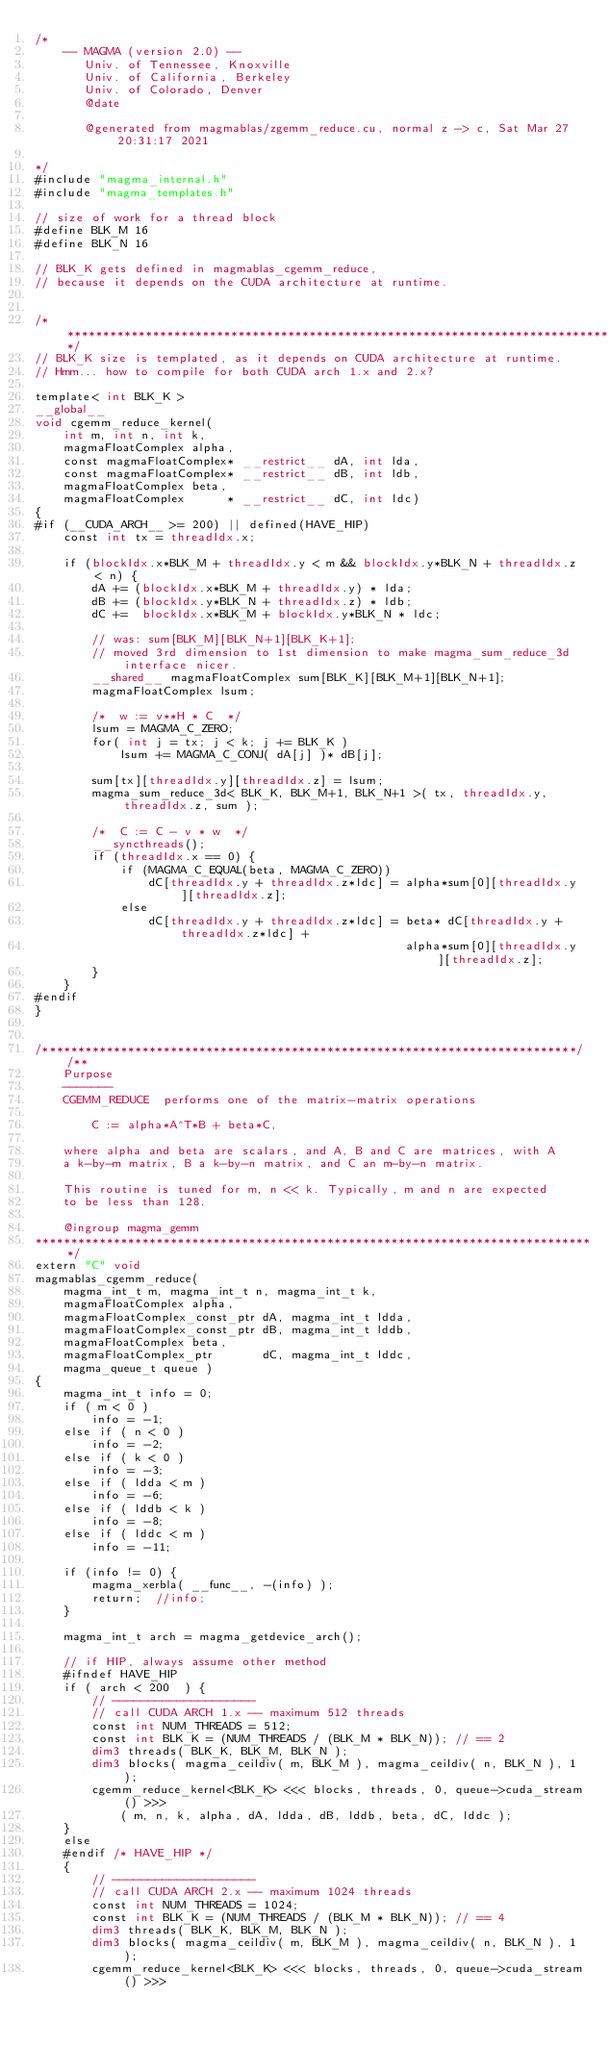<code> <loc_0><loc_0><loc_500><loc_500><_Cuda_>/*
    -- MAGMA (version 2.0) --
       Univ. of Tennessee, Knoxville
       Univ. of California, Berkeley
       Univ. of Colorado, Denver
       @date

       @generated from magmablas/zgemm_reduce.cu, normal z -> c, Sat Mar 27 20:31:17 2021

*/
#include "magma_internal.h"
#include "magma_templates.h"

// size of work for a thread block
#define BLK_M 16
#define BLK_N 16

// BLK_K gets defined in magmablas_cgemm_reduce,
// because it depends on the CUDA architecture at runtime.


/******************************************************************************/
// BLK_K size is templated, as it depends on CUDA architecture at runtime.
// Hmm... how to compile for both CUDA arch 1.x and 2.x?

template< int BLK_K >
__global__
void cgemm_reduce_kernel(
    int m, int n, int k,
    magmaFloatComplex alpha,
    const magmaFloatComplex* __restrict__ dA, int lda,
    const magmaFloatComplex* __restrict__ dB, int ldb,
    magmaFloatComplex beta,
    magmaFloatComplex      * __restrict__ dC, int ldc)
{
#if (__CUDA_ARCH__ >= 200) || defined(HAVE_HIP)
    const int tx = threadIdx.x;
    
    if (blockIdx.x*BLK_M + threadIdx.y < m && blockIdx.y*BLK_N + threadIdx.z < n) {
        dA += (blockIdx.x*BLK_M + threadIdx.y) * lda;
        dB += (blockIdx.y*BLK_N + threadIdx.z) * ldb;
        dC +=  blockIdx.x*BLK_M + blockIdx.y*BLK_N * ldc;
        
        // was: sum[BLK_M][BLK_N+1][BLK_K+1];
        // moved 3rd dimension to 1st dimension to make magma_sum_reduce_3d interface nicer.
        __shared__ magmaFloatComplex sum[BLK_K][BLK_M+1][BLK_N+1];
        magmaFloatComplex lsum;
        
        /*  w := v**H * C  */
        lsum = MAGMA_C_ZERO;
        for( int j = tx; j < k; j += BLK_K )
            lsum += MAGMA_C_CONJ( dA[j] )* dB[j];
        
        sum[tx][threadIdx.y][threadIdx.z] = lsum;
        magma_sum_reduce_3d< BLK_K, BLK_M+1, BLK_N+1 >( tx, threadIdx.y, threadIdx.z, sum );
        
        /*  C := C - v * w  */
        __syncthreads();
        if (threadIdx.x == 0) {
            if (MAGMA_C_EQUAL(beta, MAGMA_C_ZERO))
                dC[threadIdx.y + threadIdx.z*ldc] = alpha*sum[0][threadIdx.y][threadIdx.z];
            else
                dC[threadIdx.y + threadIdx.z*ldc] = beta* dC[threadIdx.y + threadIdx.z*ldc] +
                                                    alpha*sum[0][threadIdx.y][threadIdx.z];
        }
    }
#endif
}


/***************************************************************************//**
    Purpose
    -------
    CGEMM_REDUCE  performs one of the matrix-matrix operations
    
        C := alpha*A^T*B + beta*C,
    
    where alpha and beta are scalars, and A, B and C are matrices, with A
    a k-by-m matrix, B a k-by-n matrix, and C an m-by-n matrix.
    
    This routine is tuned for m, n << k. Typically, m and n are expected
    to be less than 128.

    @ingroup magma_gemm
*******************************************************************************/
extern "C" void
magmablas_cgemm_reduce(
    magma_int_t m, magma_int_t n, magma_int_t k,
    magmaFloatComplex alpha,
    magmaFloatComplex_const_ptr dA, magma_int_t ldda,
    magmaFloatComplex_const_ptr dB, magma_int_t lddb,
    magmaFloatComplex beta,
    magmaFloatComplex_ptr       dC, magma_int_t lddc,
    magma_queue_t queue )
{
    magma_int_t info = 0;
    if ( m < 0 )
        info = -1;
    else if ( n < 0 )
        info = -2;
    else if ( k < 0 )
        info = -3;
    else if ( ldda < m )
        info = -6;
    else if ( lddb < k )
        info = -8;
    else if ( lddc < m )
        info = -11;
    
    if (info != 0) {
        magma_xerbla( __func__, -(info) );
        return;  //info;
    }
    
    magma_int_t arch = magma_getdevice_arch();

    // if HIP, always assume other method
    #ifndef HAVE_HIP
    if ( arch < 200  ) {
        // --------------------
        // call CUDA ARCH 1.x -- maximum 512 threads
        const int NUM_THREADS = 512;
        const int BLK_K = (NUM_THREADS / (BLK_M * BLK_N)); // == 2
        dim3 threads( BLK_K, BLK_M, BLK_N );
        dim3 blocks( magma_ceildiv( m, BLK_M ), magma_ceildiv( n, BLK_N ), 1 );
        cgemm_reduce_kernel<BLK_K> <<< blocks, threads, 0, queue->cuda_stream() >>>
            ( m, n, k, alpha, dA, ldda, dB, lddb, beta, dC, lddc );
    }
    else 
    #endif /* HAVE_HIP */
    {
        // --------------------
        // call CUDA ARCH 2.x -- maximum 1024 threads
        const int NUM_THREADS = 1024;
        const int BLK_K = (NUM_THREADS / (BLK_M * BLK_N)); // == 4
        dim3 threads( BLK_K, BLK_M, BLK_N );
        dim3 blocks( magma_ceildiv( m, BLK_M ), magma_ceildiv( n, BLK_N ), 1 );
        cgemm_reduce_kernel<BLK_K> <<< blocks, threads, 0, queue->cuda_stream() >>></code> 